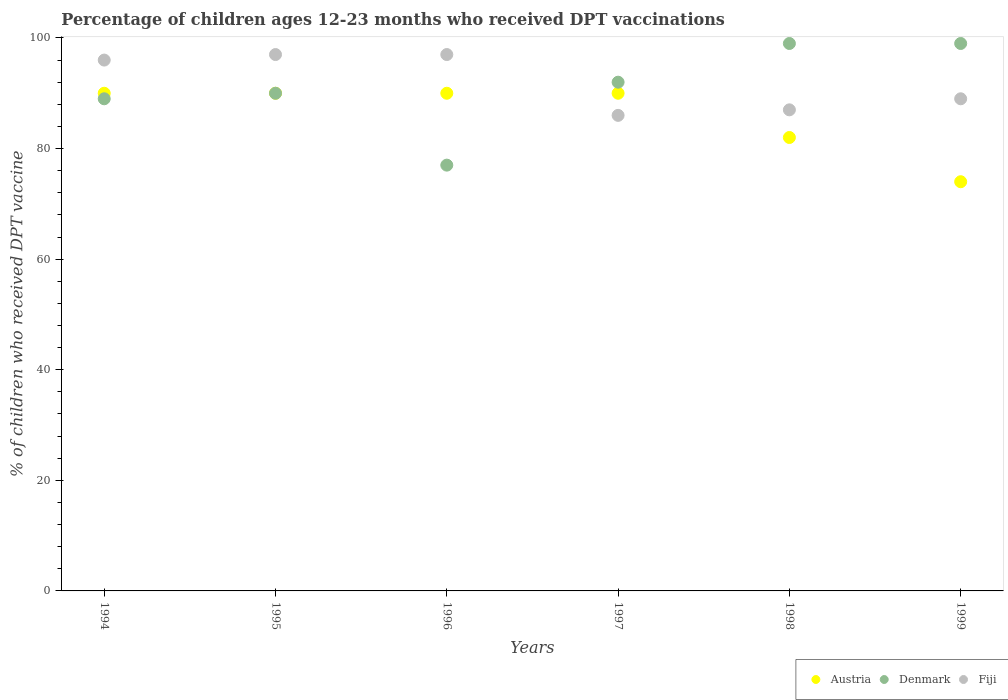What is the percentage of children who received DPT vaccination in Fiji in 1997?
Provide a succinct answer. 86. Across all years, what is the maximum percentage of children who received DPT vaccination in Denmark?
Your response must be concise. 99. Across all years, what is the minimum percentage of children who received DPT vaccination in Denmark?
Give a very brief answer. 77. What is the total percentage of children who received DPT vaccination in Austria in the graph?
Provide a short and direct response. 516. What is the difference between the percentage of children who received DPT vaccination in Fiji in 1994 and that in 1996?
Offer a terse response. -1. What is the difference between the percentage of children who received DPT vaccination in Fiji in 1995 and the percentage of children who received DPT vaccination in Austria in 1997?
Your answer should be compact. 7. What is the average percentage of children who received DPT vaccination in Denmark per year?
Your answer should be very brief. 91. In the year 1995, what is the difference between the percentage of children who received DPT vaccination in Austria and percentage of children who received DPT vaccination in Denmark?
Your response must be concise. 0. What is the ratio of the percentage of children who received DPT vaccination in Austria in 1995 to that in 1998?
Provide a short and direct response. 1.1. Is the percentage of children who received DPT vaccination in Fiji in 1996 less than that in 1998?
Ensure brevity in your answer.  No. Is the difference between the percentage of children who received DPT vaccination in Austria in 1994 and 1997 greater than the difference between the percentage of children who received DPT vaccination in Denmark in 1994 and 1997?
Give a very brief answer. Yes. What is the difference between the highest and the second highest percentage of children who received DPT vaccination in Denmark?
Your response must be concise. 0. What is the difference between the highest and the lowest percentage of children who received DPT vaccination in Denmark?
Your answer should be compact. 22. In how many years, is the percentage of children who received DPT vaccination in Austria greater than the average percentage of children who received DPT vaccination in Austria taken over all years?
Your response must be concise. 4. Is the sum of the percentage of children who received DPT vaccination in Fiji in 1994 and 1998 greater than the maximum percentage of children who received DPT vaccination in Denmark across all years?
Make the answer very short. Yes. Is it the case that in every year, the sum of the percentage of children who received DPT vaccination in Austria and percentage of children who received DPT vaccination in Denmark  is greater than the percentage of children who received DPT vaccination in Fiji?
Ensure brevity in your answer.  Yes. Is the percentage of children who received DPT vaccination in Fiji strictly greater than the percentage of children who received DPT vaccination in Denmark over the years?
Give a very brief answer. No. How many dotlines are there?
Provide a succinct answer. 3. How many years are there in the graph?
Provide a succinct answer. 6. What is the difference between two consecutive major ticks on the Y-axis?
Offer a terse response. 20. Are the values on the major ticks of Y-axis written in scientific E-notation?
Your response must be concise. No. What is the title of the graph?
Your response must be concise. Percentage of children ages 12-23 months who received DPT vaccinations. Does "Bulgaria" appear as one of the legend labels in the graph?
Offer a terse response. No. What is the label or title of the Y-axis?
Make the answer very short. % of children who received DPT vaccine. What is the % of children who received DPT vaccine in Austria in 1994?
Make the answer very short. 90. What is the % of children who received DPT vaccine in Denmark in 1994?
Make the answer very short. 89. What is the % of children who received DPT vaccine of Fiji in 1994?
Your answer should be very brief. 96. What is the % of children who received DPT vaccine of Austria in 1995?
Give a very brief answer. 90. What is the % of children who received DPT vaccine of Fiji in 1995?
Keep it short and to the point. 97. What is the % of children who received DPT vaccine in Fiji in 1996?
Provide a short and direct response. 97. What is the % of children who received DPT vaccine of Denmark in 1997?
Keep it short and to the point. 92. What is the % of children who received DPT vaccine of Fiji in 1997?
Your answer should be very brief. 86. What is the % of children who received DPT vaccine in Denmark in 1998?
Ensure brevity in your answer.  99. What is the % of children who received DPT vaccine in Fiji in 1998?
Make the answer very short. 87. What is the % of children who received DPT vaccine of Fiji in 1999?
Your answer should be very brief. 89. Across all years, what is the maximum % of children who received DPT vaccine of Austria?
Offer a terse response. 90. Across all years, what is the maximum % of children who received DPT vaccine of Fiji?
Offer a very short reply. 97. Across all years, what is the minimum % of children who received DPT vaccine of Austria?
Your response must be concise. 74. Across all years, what is the minimum % of children who received DPT vaccine of Fiji?
Provide a short and direct response. 86. What is the total % of children who received DPT vaccine in Austria in the graph?
Provide a short and direct response. 516. What is the total % of children who received DPT vaccine of Denmark in the graph?
Provide a succinct answer. 546. What is the total % of children who received DPT vaccine in Fiji in the graph?
Your answer should be very brief. 552. What is the difference between the % of children who received DPT vaccine in Austria in 1994 and that in 1995?
Your answer should be very brief. 0. What is the difference between the % of children who received DPT vaccine of Denmark in 1994 and that in 1995?
Offer a terse response. -1. What is the difference between the % of children who received DPT vaccine of Fiji in 1994 and that in 1996?
Ensure brevity in your answer.  -1. What is the difference between the % of children who received DPT vaccine of Denmark in 1994 and that in 1997?
Your answer should be compact. -3. What is the difference between the % of children who received DPT vaccine in Austria in 1994 and that in 1998?
Your answer should be very brief. 8. What is the difference between the % of children who received DPT vaccine in Fiji in 1994 and that in 1998?
Your answer should be compact. 9. What is the difference between the % of children who received DPT vaccine in Austria in 1994 and that in 1999?
Offer a very short reply. 16. What is the difference between the % of children who received DPT vaccine in Denmark in 1995 and that in 1996?
Provide a succinct answer. 13. What is the difference between the % of children who received DPT vaccine in Fiji in 1995 and that in 1996?
Provide a succinct answer. 0. What is the difference between the % of children who received DPT vaccine in Austria in 1995 and that in 1997?
Offer a terse response. 0. What is the difference between the % of children who received DPT vaccine of Fiji in 1995 and that in 1997?
Offer a very short reply. 11. What is the difference between the % of children who received DPT vaccine in Austria in 1995 and that in 1998?
Offer a terse response. 8. What is the difference between the % of children who received DPT vaccine in Austria in 1995 and that in 1999?
Provide a succinct answer. 16. What is the difference between the % of children who received DPT vaccine in Denmark in 1995 and that in 1999?
Your answer should be very brief. -9. What is the difference between the % of children who received DPT vaccine of Austria in 1996 and that in 1997?
Your response must be concise. 0. What is the difference between the % of children who received DPT vaccine of Fiji in 1996 and that in 1997?
Your answer should be compact. 11. What is the difference between the % of children who received DPT vaccine in Denmark in 1996 and that in 1999?
Give a very brief answer. -22. What is the difference between the % of children who received DPT vaccine of Denmark in 1997 and that in 1998?
Offer a terse response. -7. What is the difference between the % of children who received DPT vaccine in Fiji in 1997 and that in 1998?
Your answer should be compact. -1. What is the difference between the % of children who received DPT vaccine of Austria in 1997 and that in 1999?
Offer a terse response. 16. What is the difference between the % of children who received DPT vaccine in Denmark in 1997 and that in 1999?
Offer a terse response. -7. What is the difference between the % of children who received DPT vaccine in Fiji in 1997 and that in 1999?
Your answer should be very brief. -3. What is the difference between the % of children who received DPT vaccine of Austria in 1998 and that in 1999?
Your answer should be very brief. 8. What is the difference between the % of children who received DPT vaccine of Denmark in 1998 and that in 1999?
Provide a succinct answer. 0. What is the difference between the % of children who received DPT vaccine in Fiji in 1998 and that in 1999?
Your answer should be compact. -2. What is the difference between the % of children who received DPT vaccine in Austria in 1994 and the % of children who received DPT vaccine in Denmark in 1995?
Provide a short and direct response. 0. What is the difference between the % of children who received DPT vaccine of Austria in 1994 and the % of children who received DPT vaccine of Fiji in 1995?
Give a very brief answer. -7. What is the difference between the % of children who received DPT vaccine in Austria in 1994 and the % of children who received DPT vaccine in Denmark in 1996?
Provide a succinct answer. 13. What is the difference between the % of children who received DPT vaccine in Denmark in 1994 and the % of children who received DPT vaccine in Fiji in 1996?
Offer a very short reply. -8. What is the difference between the % of children who received DPT vaccine of Austria in 1994 and the % of children who received DPT vaccine of Fiji in 1997?
Offer a terse response. 4. What is the difference between the % of children who received DPT vaccine of Denmark in 1994 and the % of children who received DPT vaccine of Fiji in 1997?
Your answer should be compact. 3. What is the difference between the % of children who received DPT vaccine in Austria in 1994 and the % of children who received DPT vaccine in Fiji in 1998?
Keep it short and to the point. 3. What is the difference between the % of children who received DPT vaccine of Denmark in 1994 and the % of children who received DPT vaccine of Fiji in 1998?
Ensure brevity in your answer.  2. What is the difference between the % of children who received DPT vaccine in Austria in 1994 and the % of children who received DPT vaccine in Fiji in 1999?
Offer a terse response. 1. What is the difference between the % of children who received DPT vaccine in Denmark in 1994 and the % of children who received DPT vaccine in Fiji in 1999?
Provide a succinct answer. 0. What is the difference between the % of children who received DPT vaccine of Austria in 1995 and the % of children who received DPT vaccine of Denmark in 1996?
Your response must be concise. 13. What is the difference between the % of children who received DPT vaccine of Austria in 1995 and the % of children who received DPT vaccine of Fiji in 1996?
Offer a terse response. -7. What is the difference between the % of children who received DPT vaccine of Denmark in 1995 and the % of children who received DPT vaccine of Fiji in 1996?
Offer a terse response. -7. What is the difference between the % of children who received DPT vaccine of Austria in 1995 and the % of children who received DPT vaccine of Denmark in 1997?
Your response must be concise. -2. What is the difference between the % of children who received DPT vaccine in Austria in 1995 and the % of children who received DPT vaccine in Fiji in 1997?
Make the answer very short. 4. What is the difference between the % of children who received DPT vaccine of Denmark in 1995 and the % of children who received DPT vaccine of Fiji in 1997?
Your answer should be compact. 4. What is the difference between the % of children who received DPT vaccine of Austria in 1995 and the % of children who received DPT vaccine of Denmark in 1998?
Your answer should be compact. -9. What is the difference between the % of children who received DPT vaccine of Austria in 1995 and the % of children who received DPT vaccine of Fiji in 1998?
Offer a very short reply. 3. What is the difference between the % of children who received DPT vaccine of Austria in 1995 and the % of children who received DPT vaccine of Denmark in 1999?
Provide a succinct answer. -9. What is the difference between the % of children who received DPT vaccine in Austria in 1995 and the % of children who received DPT vaccine in Fiji in 1999?
Give a very brief answer. 1. What is the difference between the % of children who received DPT vaccine of Denmark in 1995 and the % of children who received DPT vaccine of Fiji in 1999?
Your answer should be very brief. 1. What is the difference between the % of children who received DPT vaccine of Austria in 1996 and the % of children who received DPT vaccine of Fiji in 1997?
Provide a succinct answer. 4. What is the difference between the % of children who received DPT vaccine in Austria in 1996 and the % of children who received DPT vaccine in Fiji in 1999?
Provide a succinct answer. 1. What is the difference between the % of children who received DPT vaccine of Denmark in 1996 and the % of children who received DPT vaccine of Fiji in 1999?
Keep it short and to the point. -12. What is the difference between the % of children who received DPT vaccine of Austria in 1997 and the % of children who received DPT vaccine of Denmark in 1998?
Your response must be concise. -9. What is the difference between the % of children who received DPT vaccine of Austria in 1997 and the % of children who received DPT vaccine of Fiji in 1998?
Ensure brevity in your answer.  3. What is the difference between the % of children who received DPT vaccine in Denmark in 1997 and the % of children who received DPT vaccine in Fiji in 1998?
Offer a very short reply. 5. What is the difference between the % of children who received DPT vaccine in Austria in 1997 and the % of children who received DPT vaccine in Denmark in 1999?
Give a very brief answer. -9. What is the difference between the % of children who received DPT vaccine in Austria in 1997 and the % of children who received DPT vaccine in Fiji in 1999?
Provide a succinct answer. 1. What is the difference between the % of children who received DPT vaccine in Austria in 1998 and the % of children who received DPT vaccine in Denmark in 1999?
Offer a terse response. -17. What is the difference between the % of children who received DPT vaccine of Denmark in 1998 and the % of children who received DPT vaccine of Fiji in 1999?
Offer a very short reply. 10. What is the average % of children who received DPT vaccine in Denmark per year?
Offer a very short reply. 91. What is the average % of children who received DPT vaccine in Fiji per year?
Your response must be concise. 92. In the year 1994, what is the difference between the % of children who received DPT vaccine of Austria and % of children who received DPT vaccine of Denmark?
Offer a terse response. 1. In the year 1994, what is the difference between the % of children who received DPT vaccine of Austria and % of children who received DPT vaccine of Fiji?
Provide a short and direct response. -6. In the year 1996, what is the difference between the % of children who received DPT vaccine in Austria and % of children who received DPT vaccine in Fiji?
Keep it short and to the point. -7. In the year 1996, what is the difference between the % of children who received DPT vaccine of Denmark and % of children who received DPT vaccine of Fiji?
Your response must be concise. -20. In the year 1997, what is the difference between the % of children who received DPT vaccine in Austria and % of children who received DPT vaccine in Denmark?
Provide a succinct answer. -2. In the year 1997, what is the difference between the % of children who received DPT vaccine in Austria and % of children who received DPT vaccine in Fiji?
Your answer should be very brief. 4. In the year 1998, what is the difference between the % of children who received DPT vaccine in Austria and % of children who received DPT vaccine in Fiji?
Keep it short and to the point. -5. In the year 1998, what is the difference between the % of children who received DPT vaccine of Denmark and % of children who received DPT vaccine of Fiji?
Provide a succinct answer. 12. In the year 1999, what is the difference between the % of children who received DPT vaccine of Denmark and % of children who received DPT vaccine of Fiji?
Offer a very short reply. 10. What is the ratio of the % of children who received DPT vaccine in Austria in 1994 to that in 1995?
Keep it short and to the point. 1. What is the ratio of the % of children who received DPT vaccine of Denmark in 1994 to that in 1995?
Ensure brevity in your answer.  0.99. What is the ratio of the % of children who received DPT vaccine in Austria in 1994 to that in 1996?
Provide a short and direct response. 1. What is the ratio of the % of children who received DPT vaccine in Denmark in 1994 to that in 1996?
Your response must be concise. 1.16. What is the ratio of the % of children who received DPT vaccine of Fiji in 1994 to that in 1996?
Ensure brevity in your answer.  0.99. What is the ratio of the % of children who received DPT vaccine of Austria in 1994 to that in 1997?
Provide a short and direct response. 1. What is the ratio of the % of children who received DPT vaccine in Denmark in 1994 to that in 1997?
Provide a succinct answer. 0.97. What is the ratio of the % of children who received DPT vaccine in Fiji in 1994 to that in 1997?
Give a very brief answer. 1.12. What is the ratio of the % of children who received DPT vaccine of Austria in 1994 to that in 1998?
Offer a terse response. 1.1. What is the ratio of the % of children who received DPT vaccine of Denmark in 1994 to that in 1998?
Ensure brevity in your answer.  0.9. What is the ratio of the % of children who received DPT vaccine of Fiji in 1994 to that in 1998?
Ensure brevity in your answer.  1.1. What is the ratio of the % of children who received DPT vaccine of Austria in 1994 to that in 1999?
Provide a succinct answer. 1.22. What is the ratio of the % of children who received DPT vaccine in Denmark in 1994 to that in 1999?
Ensure brevity in your answer.  0.9. What is the ratio of the % of children who received DPT vaccine in Fiji in 1994 to that in 1999?
Provide a short and direct response. 1.08. What is the ratio of the % of children who received DPT vaccine in Austria in 1995 to that in 1996?
Offer a very short reply. 1. What is the ratio of the % of children who received DPT vaccine in Denmark in 1995 to that in 1996?
Offer a very short reply. 1.17. What is the ratio of the % of children who received DPT vaccine of Austria in 1995 to that in 1997?
Give a very brief answer. 1. What is the ratio of the % of children who received DPT vaccine of Denmark in 1995 to that in 1997?
Offer a terse response. 0.98. What is the ratio of the % of children who received DPT vaccine in Fiji in 1995 to that in 1997?
Provide a succinct answer. 1.13. What is the ratio of the % of children who received DPT vaccine in Austria in 1995 to that in 1998?
Provide a succinct answer. 1.1. What is the ratio of the % of children who received DPT vaccine in Denmark in 1995 to that in 1998?
Offer a very short reply. 0.91. What is the ratio of the % of children who received DPT vaccine of Fiji in 1995 to that in 1998?
Provide a short and direct response. 1.11. What is the ratio of the % of children who received DPT vaccine in Austria in 1995 to that in 1999?
Give a very brief answer. 1.22. What is the ratio of the % of children who received DPT vaccine in Denmark in 1995 to that in 1999?
Your response must be concise. 0.91. What is the ratio of the % of children who received DPT vaccine of Fiji in 1995 to that in 1999?
Make the answer very short. 1.09. What is the ratio of the % of children who received DPT vaccine in Denmark in 1996 to that in 1997?
Your response must be concise. 0.84. What is the ratio of the % of children who received DPT vaccine of Fiji in 1996 to that in 1997?
Your answer should be very brief. 1.13. What is the ratio of the % of children who received DPT vaccine in Austria in 1996 to that in 1998?
Ensure brevity in your answer.  1.1. What is the ratio of the % of children who received DPT vaccine in Fiji in 1996 to that in 1998?
Ensure brevity in your answer.  1.11. What is the ratio of the % of children who received DPT vaccine of Austria in 1996 to that in 1999?
Your answer should be very brief. 1.22. What is the ratio of the % of children who received DPT vaccine of Denmark in 1996 to that in 1999?
Your response must be concise. 0.78. What is the ratio of the % of children who received DPT vaccine in Fiji in 1996 to that in 1999?
Provide a short and direct response. 1.09. What is the ratio of the % of children who received DPT vaccine of Austria in 1997 to that in 1998?
Offer a terse response. 1.1. What is the ratio of the % of children who received DPT vaccine of Denmark in 1997 to that in 1998?
Offer a terse response. 0.93. What is the ratio of the % of children who received DPT vaccine in Fiji in 1997 to that in 1998?
Offer a very short reply. 0.99. What is the ratio of the % of children who received DPT vaccine in Austria in 1997 to that in 1999?
Provide a succinct answer. 1.22. What is the ratio of the % of children who received DPT vaccine of Denmark in 1997 to that in 1999?
Offer a terse response. 0.93. What is the ratio of the % of children who received DPT vaccine in Fiji in 1997 to that in 1999?
Provide a succinct answer. 0.97. What is the ratio of the % of children who received DPT vaccine in Austria in 1998 to that in 1999?
Provide a succinct answer. 1.11. What is the ratio of the % of children who received DPT vaccine of Fiji in 1998 to that in 1999?
Offer a terse response. 0.98. What is the difference between the highest and the second highest % of children who received DPT vaccine in Austria?
Make the answer very short. 0. What is the difference between the highest and the second highest % of children who received DPT vaccine of Denmark?
Make the answer very short. 0. What is the difference between the highest and the second highest % of children who received DPT vaccine of Fiji?
Provide a succinct answer. 0. What is the difference between the highest and the lowest % of children who received DPT vaccine in Fiji?
Provide a short and direct response. 11. 